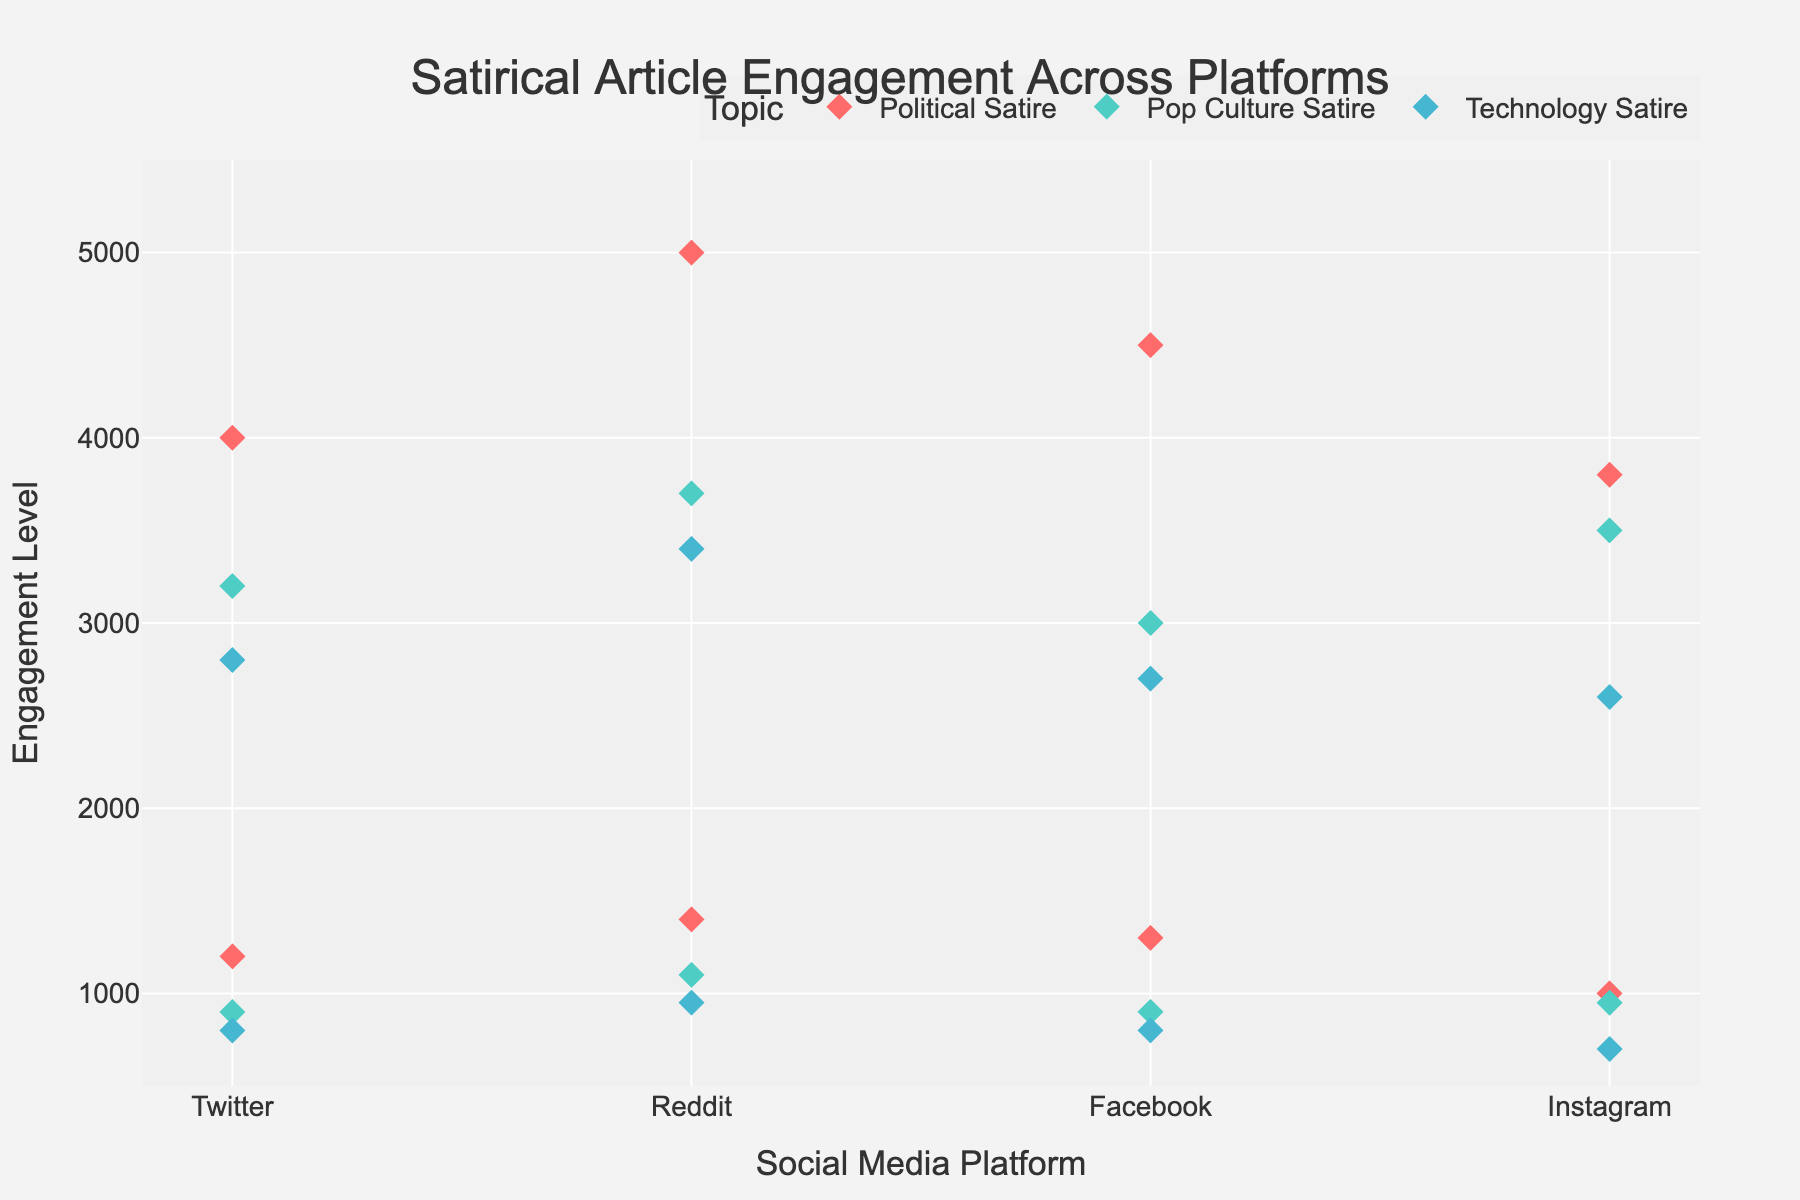what is the range of engagements for Political Satire on Twitter? The range of engagements is found between the Min and Max Engagement values for Political Satire on Twitter. For Twitter, the Min Engagement for Political Satire is 1200, and the Max Engagement is 4000. Therefore, the range is from 1200 to 4000.
Answer: 1200 to 4000 What platform has the highest maximum engagement for Pop Culture Satire? To find the platform with the highest maximum engagement for Pop Culture Satire, we compare the Max Engagement values for that topic across all platforms. Twitter has 3200, Reddit has 3700, Facebook has 3000, and Instagram has 3500. Reddit has the highest maximum engagement at 3700.
Answer: Reddit Which media platform has the smallest range for Technology Satire engagement? For each platform, calculate the range by subtracting the Min Engagement from the Max Engagement for Technology Satire. Twitter: (2800-800)=2000, Reddit: (3400-950)=2450, Facebook: (2700-800)=1900, Instagram: (2600-700)=1900. Facebook and Instagram both have the smallest range of 1900.
Answer: Facebook and Instagram Between Reddit and Facebook, which has higher average engagement for Political Satire? Calculate the average engagement for Political Satire on both platforms by summing Min and Max Engagement and dividing by 2. For Reddit: (1400 + 5000) / 2 = 3200, and for Facebook: (1300 + 4500) / 2 = 2900. Reddit has the higher average engagement.
Answer: Reddit What is the difference in maximum engagement for Technology Satire between Reddit and Facebook? Subtract the Max Engagement of Technology Satire on Facebook from that on Reddit. For Reddit, it's 3400, and for Facebook, it's 2700. The difference is 3400 - 2700 = 700.
Answer: 700 Which topic has the lowest minimum engagement on any platform? Compare the Min Engagement across all topics and platforms. The lowest Min Engagement values observed are for Technology Satire on Instagram and Facebook, both at 700.
Answer: Technology Satire on Instagram and Facebook How does the engagement range of Pop Culture Satire on Instagram compare to that on Twitter? First, find the range by subtracting the Min from the Max Engagement for both platforms. For Instagram, the range is 3500 - 950 = 2550. For Twitter, the range is 3200 - 900 = 2300. Therefore, engagements on Instagram have a larger range by 2550 - 2300 = 250.
Answer: Instagram has a 250 larger range Which topic shows the highest engagement range on Reddit? To find the highest engagement range, calculate the difference between Max and Min Engagement for each topic on Reddit. Political Satire: (5000 - 1400) = 3600, Pop Culture Satire: (3700 - 1100) = 2600, Technology Satire: (3400 - 950) = 2450. Political Satire has the highest range at 3600.
Answer: Political Satire 